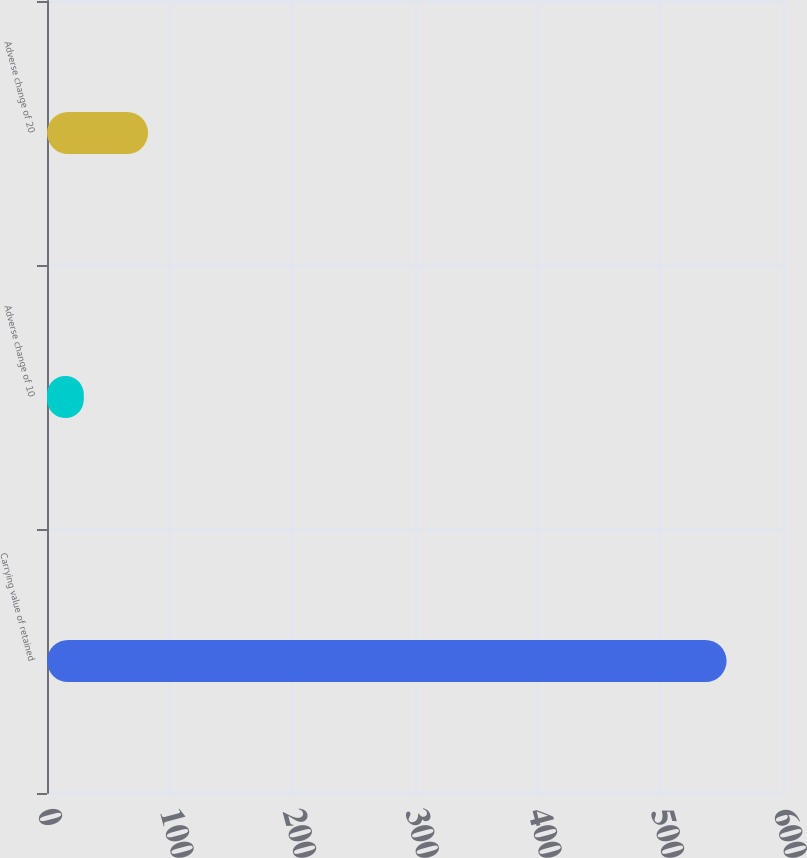Convert chart. <chart><loc_0><loc_0><loc_500><loc_500><bar_chart><fcel>Carrying value of retained<fcel>Adverse change of 10<fcel>Adverse change of 20<nl><fcel>554<fcel>30<fcel>82.4<nl></chart> 